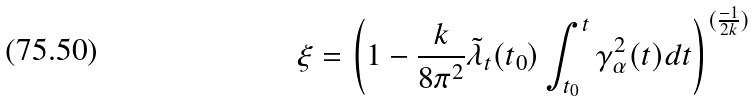Convert formula to latex. <formula><loc_0><loc_0><loc_500><loc_500>\xi = \left ( 1 - \frac { k } { 8 \pi ^ { 2 } } { \tilde { \lambda } } _ { t } ( t _ { 0 } ) \int _ { t _ { 0 } } ^ { t } \gamma _ { \alpha } ^ { 2 } ( t ) d t \right ) ^ { ( \frac { - 1 } { 2 k } ) }</formula> 